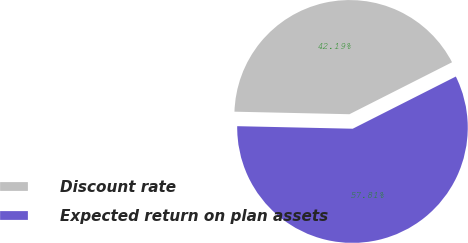Convert chart to OTSL. <chart><loc_0><loc_0><loc_500><loc_500><pie_chart><fcel>Discount rate<fcel>Expected return on plan assets<nl><fcel>42.19%<fcel>57.81%<nl></chart> 